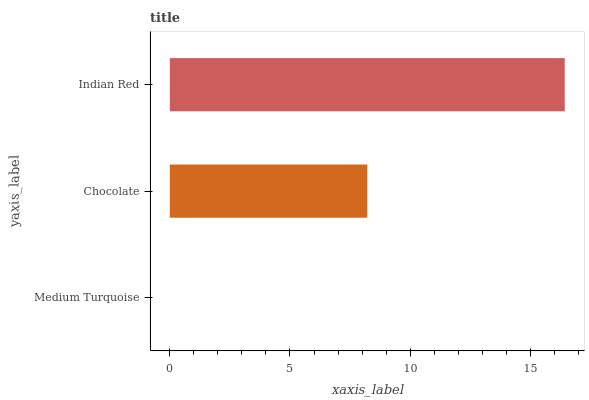Is Medium Turquoise the minimum?
Answer yes or no. Yes. Is Indian Red the maximum?
Answer yes or no. Yes. Is Chocolate the minimum?
Answer yes or no. No. Is Chocolate the maximum?
Answer yes or no. No. Is Chocolate greater than Medium Turquoise?
Answer yes or no. Yes. Is Medium Turquoise less than Chocolate?
Answer yes or no. Yes. Is Medium Turquoise greater than Chocolate?
Answer yes or no. No. Is Chocolate less than Medium Turquoise?
Answer yes or no. No. Is Chocolate the high median?
Answer yes or no. Yes. Is Chocolate the low median?
Answer yes or no. Yes. Is Indian Red the high median?
Answer yes or no. No. Is Indian Red the low median?
Answer yes or no. No. 